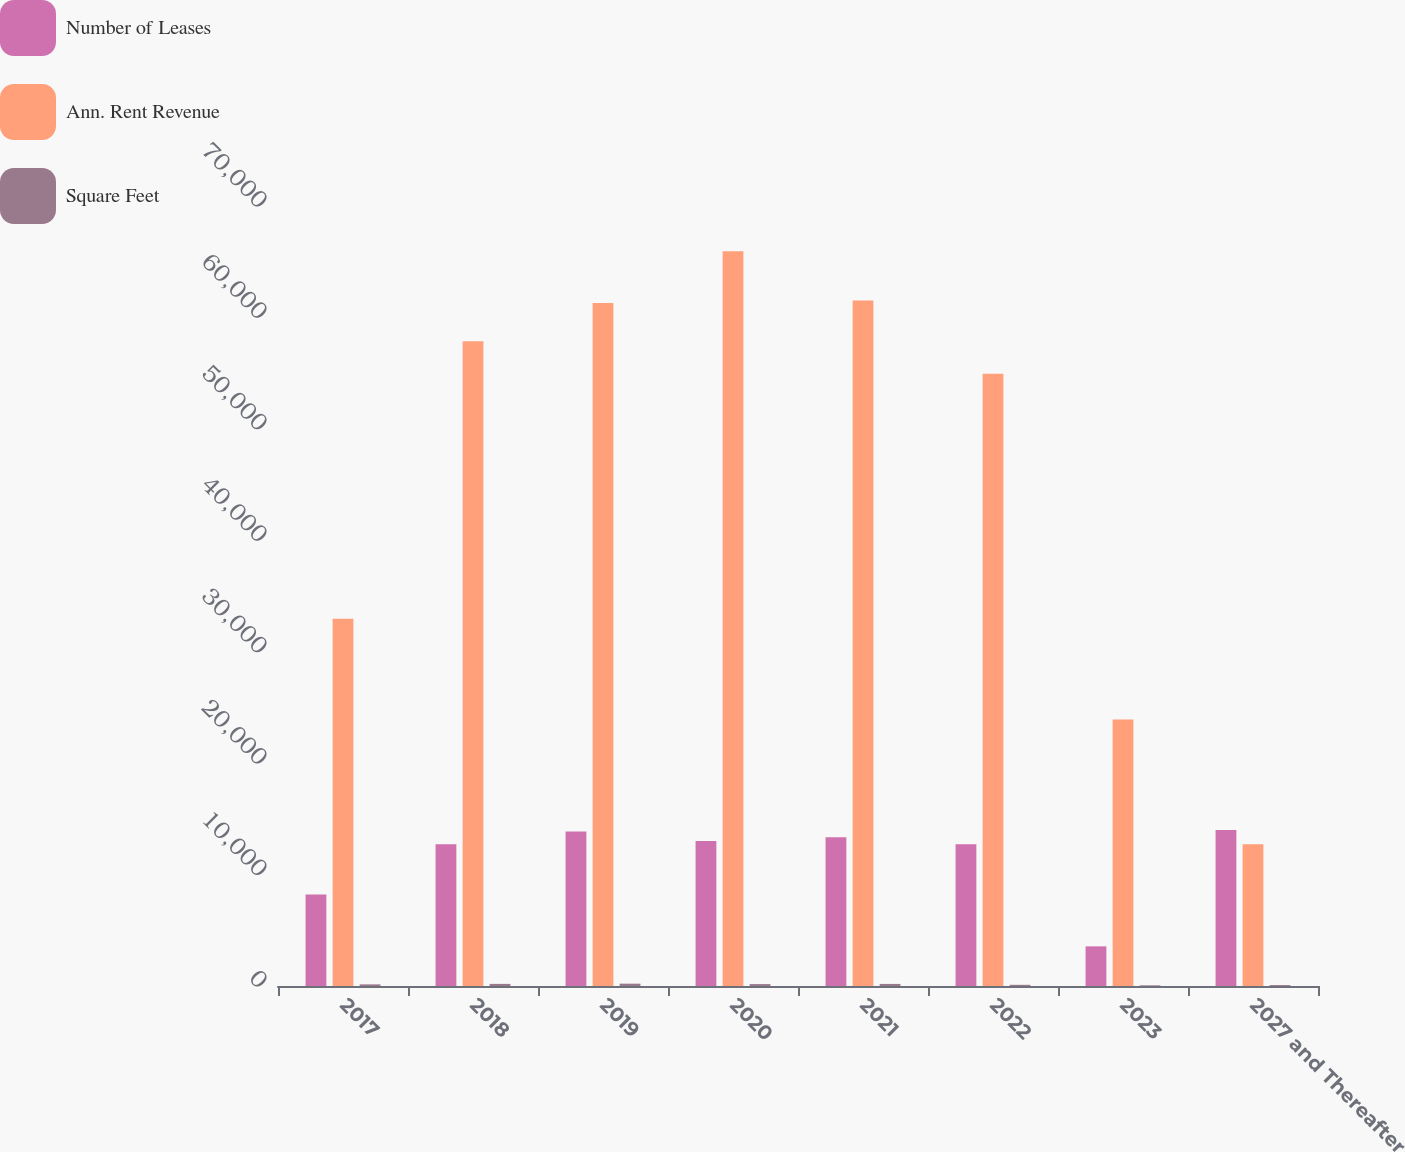Convert chart. <chart><loc_0><loc_0><loc_500><loc_500><stacked_bar_chart><ecel><fcel>2017<fcel>2018<fcel>2019<fcel>2020<fcel>2021<fcel>2022<fcel>2023<fcel>2027 and Thereafter<nl><fcel>Number of Leases<fcel>8215<fcel>12729<fcel>13858<fcel>13014<fcel>13358<fcel>12712<fcel>3557<fcel>14003<nl><fcel>Ann. Rent Revenue<fcel>32966<fcel>57870<fcel>61293<fcel>65938<fcel>61520<fcel>54950<fcel>23923<fcel>12729<nl><fcel>Square Feet<fcel>146<fcel>189<fcel>210<fcel>172<fcel>186<fcel>106<fcel>62<fcel>84<nl></chart> 